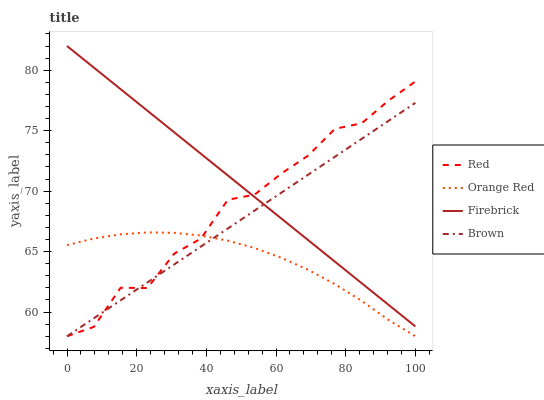Does Orange Red have the minimum area under the curve?
Answer yes or no. Yes. Does Firebrick have the maximum area under the curve?
Answer yes or no. Yes. Does Firebrick have the minimum area under the curve?
Answer yes or no. No. Does Orange Red have the maximum area under the curve?
Answer yes or no. No. Is Firebrick the smoothest?
Answer yes or no. Yes. Is Red the roughest?
Answer yes or no. Yes. Is Orange Red the smoothest?
Answer yes or no. No. Is Orange Red the roughest?
Answer yes or no. No. Does Firebrick have the lowest value?
Answer yes or no. No. Does Orange Red have the highest value?
Answer yes or no. No. Is Orange Red less than Firebrick?
Answer yes or no. Yes. Is Firebrick greater than Orange Red?
Answer yes or no. Yes. Does Orange Red intersect Firebrick?
Answer yes or no. No. 